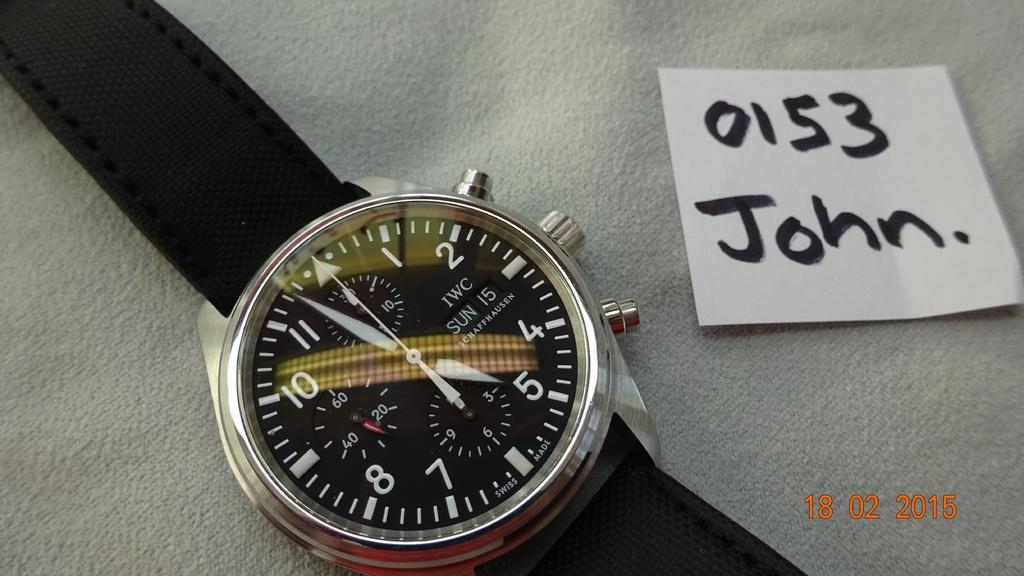What is the time right now?
Offer a terse response. 4:58. This is watch?
Provide a short and direct response. Yes. 